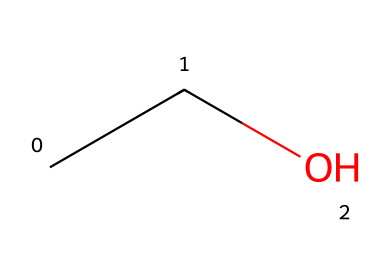How many carbon atoms are in this molecule? The SMILES representation "CCO" shows that there are two 'C' letters, which indicate the presence of two carbon atoms in the molecule.
Answer: 2 What is the functional group present in this molecule? In the SMILES "CCO", the 'O' at the end indicates the presence of an alcohol group, specifically a hydroxyl group (-OH) attached to the carbon chain.
Answer: alcohol What type of compound is this? Since the molecule has a hydroxyl functional group and contains carbon and hydrogen, it is classified as an alcohol, which is a type of organic compound.
Answer: alcohol What is the total number of hydrogen atoms in this molecule? The molecule has two carbon atoms, each typically forms 4 bonds; thus, with the formation of one hydroxyl (-OH), the total number of hydrogen atoms can be calculated as follows: 2 carbon atoms each bonded to 3 hydrogens and 1 hydrogen from the hydroxyl, leading to 5 hydrogen atoms in total.
Answer: 6 Is this molecule polar or nonpolar? The presence of the hydroxyl group, which is polar due to its ability to form hydrogen bonds, indicates that the overall polarity of the molecule is polar despite it having a nonpolar carbon chain.
Answer: polar What is the molecular formula of this compound? The SMILES "CCO" can be translated to its molecular formula by counting the atoms: there are 2 carbon atoms (C), 6 hydrogen atoms (H), and 1 oxygen atom (O), resulting in the formula C2H6O.
Answer: C2H6O 